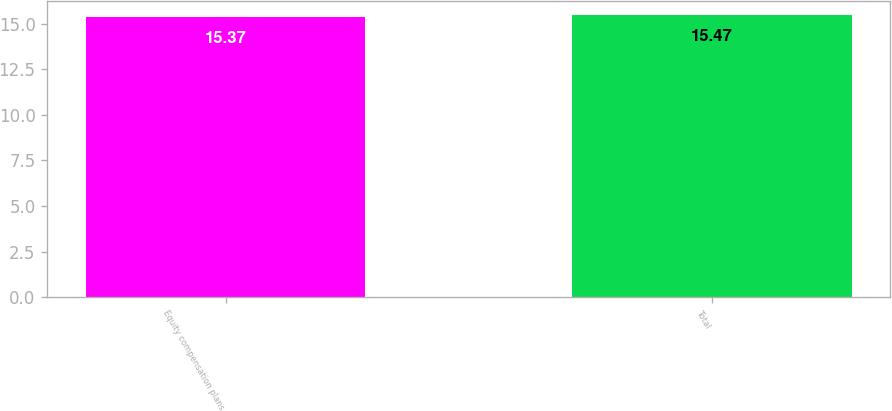Convert chart to OTSL. <chart><loc_0><loc_0><loc_500><loc_500><bar_chart><fcel>Equity compensation plans<fcel>Total<nl><fcel>15.37<fcel>15.47<nl></chart> 